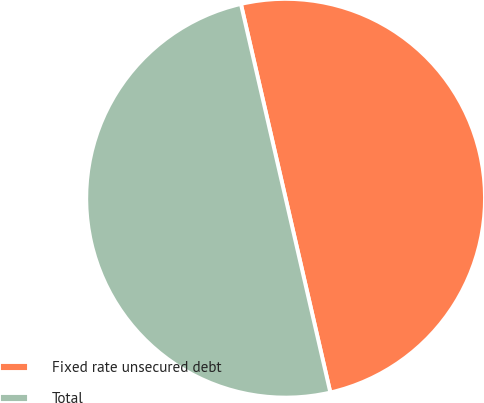Convert chart to OTSL. <chart><loc_0><loc_0><loc_500><loc_500><pie_chart><fcel>Fixed rate unsecured debt<fcel>Total<nl><fcel>50.0%<fcel>50.0%<nl></chart> 